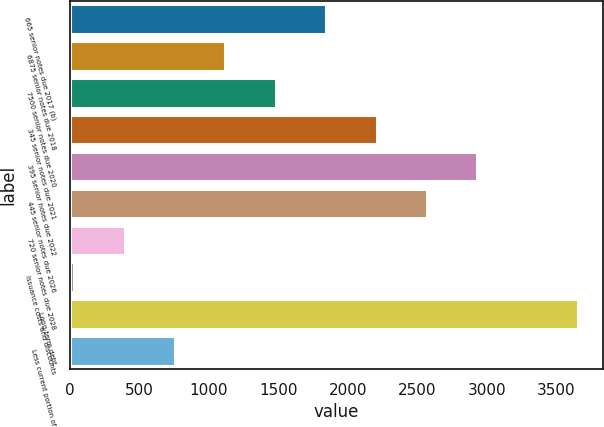Convert chart to OTSL. <chart><loc_0><loc_0><loc_500><loc_500><bar_chart><fcel>665 senior notes due 2017 (b)<fcel>6875 senior notes due 2018<fcel>7500 senior notes due 2020<fcel>345 senior notes due 2021<fcel>395 senior notes due 2022<fcel>445 senior notes due 2026<fcel>720 senior notes due 2028<fcel>Issuance costs and discounts<fcel>Long-term debt<fcel>Less current portion of<nl><fcel>1845<fcel>1121<fcel>1483<fcel>2207<fcel>2931<fcel>2569<fcel>397<fcel>35<fcel>3655<fcel>759<nl></chart> 